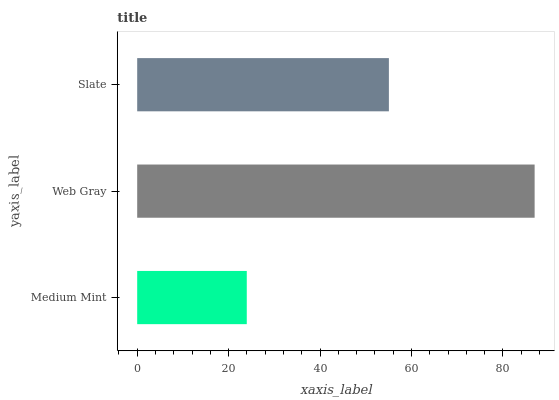Is Medium Mint the minimum?
Answer yes or no. Yes. Is Web Gray the maximum?
Answer yes or no. Yes. Is Slate the minimum?
Answer yes or no. No. Is Slate the maximum?
Answer yes or no. No. Is Web Gray greater than Slate?
Answer yes or no. Yes. Is Slate less than Web Gray?
Answer yes or no. Yes. Is Slate greater than Web Gray?
Answer yes or no. No. Is Web Gray less than Slate?
Answer yes or no. No. Is Slate the high median?
Answer yes or no. Yes. Is Slate the low median?
Answer yes or no. Yes. Is Web Gray the high median?
Answer yes or no. No. Is Web Gray the low median?
Answer yes or no. No. 